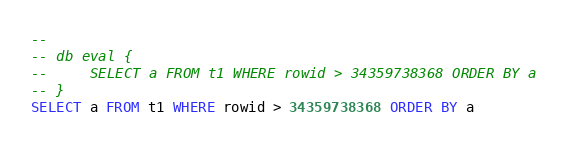<code> <loc_0><loc_0><loc_500><loc_500><_SQL_>-- 
-- db eval {
--     SELECT a FROM t1 WHERE rowid > 34359738368 ORDER BY a
-- }
SELECT a FROM t1 WHERE rowid > 34359738368 ORDER BY a</code> 